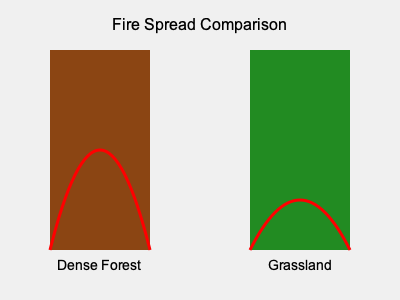Based on the graph comparing fire spread in dense forest and grassland, which vegetation type is likely to have a faster rate of fire spread during a controlled burn? To determine which vegetation type has a faster rate of fire spread, we need to analyze the graph:

1. The graph shows two vegetation types: Dense Forest (left) and Grassland (right).
2. The red curves represent the spread of fire in each vegetation type.
3. For the Dense Forest:
   - The fire spread curve is steeper and reaches higher.
   - This indicates a slower, but potentially more intense fire.
4. For the Grassland:
   - The fire spread curve is flatter and doesn't reach as high.
   - This suggests a faster, but potentially less intense fire.
5. In grasslands, fires tend to spread more quickly due to:
   - Lower fuel moisture content
   - More uniform and continuous fuel bed
   - Better oxygen circulation
6. In dense forests, fires may spread more slowly because:
   - Higher fuel moisture content in larger vegetation
   - More varied and discontinuous fuel bed
   - Less oxygen circulation due to dense canopy

Therefore, based on the graph and general fire behavior principles, the grassland is likely to have a faster rate of fire spread during a controlled burn.
Answer: Grassland 